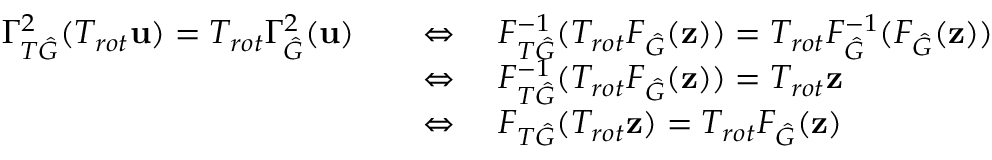Convert formula to latex. <formula><loc_0><loc_0><loc_500><loc_500>\begin{array} { r l } { \Gamma _ { T \hat { G } } ^ { 2 } ( T _ { r o t } u ) = T _ { r o t } \Gamma _ { \hat { G } } ^ { 2 } ( u ) } & { \quad \Leftrightarrow \quad F _ { T \hat { G } } ^ { - 1 } ( T _ { r o t } F _ { \hat { G } } ( z ) ) = T _ { r o t } F _ { \hat { G } } ^ { - 1 } ( F _ { \hat { G } } ( z ) ) } \\ & { \quad \Leftrightarrow \quad F _ { T \hat { G } } ^ { - 1 } ( T _ { r o t } F _ { \hat { G } } ( z ) ) = T _ { r o t } z } \\ & { \quad \Leftrightarrow \quad F _ { T \hat { G } } ( T _ { r o t } z ) = T _ { r o t } F _ { \hat { G } } ( z ) } \end{array}</formula> 